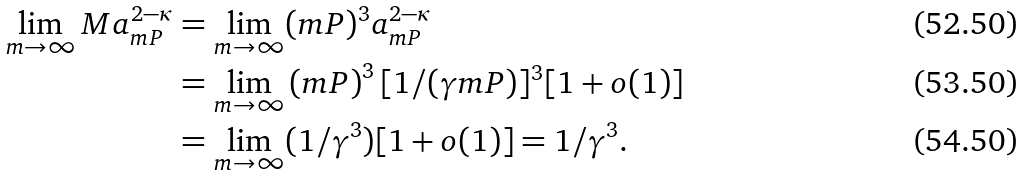<formula> <loc_0><loc_0><loc_500><loc_500>\lim _ { m \to \infty } M a _ { m P } ^ { 2 - \kappa } & = \lim _ { m \to \infty } ( m P ) ^ { 3 } a _ { m P } ^ { 2 - \kappa } \\ & = \lim _ { m \to \infty } \left ( m P \right ) ^ { 3 } [ 1 / ( \gamma m P ) ] ^ { 3 } [ 1 + o ( 1 ) ] \\ & = \lim _ { m \to \infty } ( 1 / \gamma ^ { 3 } ) [ 1 + o ( 1 ) ] = 1 / \gamma ^ { 3 } .</formula> 